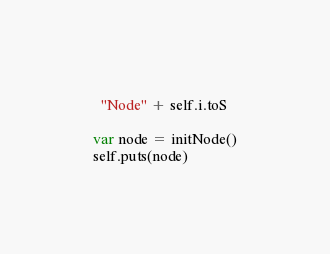Convert code to text. <code><loc_0><loc_0><loc_500><loc_500><_Nim_>  "Node" + self.i.toS

var node = initNode()
self.puts(node)
</code> 